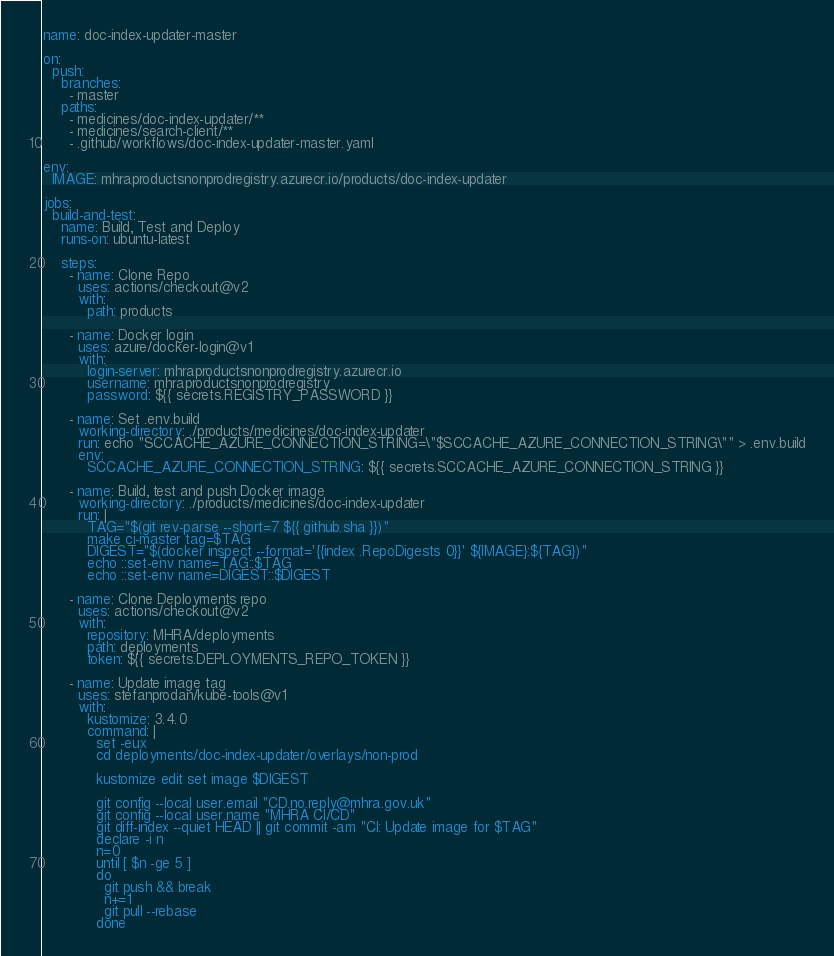<code> <loc_0><loc_0><loc_500><loc_500><_YAML_>name: doc-index-updater-master

on:
  push:
    branches:
      - master
    paths:
      - medicines/doc-index-updater/**
      - medicines/search-client/**
      - .github/workflows/doc-index-updater-master.yaml

env:
  IMAGE: mhraproductsnonprodregistry.azurecr.io/products/doc-index-updater

jobs:
  build-and-test:
    name: Build, Test and Deploy
    runs-on: ubuntu-latest

    steps:
      - name: Clone Repo
        uses: actions/checkout@v2
        with:
          path: products

      - name: Docker login
        uses: azure/docker-login@v1
        with:
          login-server: mhraproductsnonprodregistry.azurecr.io
          username: mhraproductsnonprodregistry
          password: ${{ secrets.REGISTRY_PASSWORD }}

      - name: Set .env.build
        working-directory: ./products/medicines/doc-index-updater
        run: echo "SCCACHE_AZURE_CONNECTION_STRING=\"$SCCACHE_AZURE_CONNECTION_STRING\"" > .env.build
        env:
          SCCACHE_AZURE_CONNECTION_STRING: ${{ secrets.SCCACHE_AZURE_CONNECTION_STRING }}

      - name: Build, test and push Docker image
        working-directory: ./products/medicines/doc-index-updater
        run: |
          TAG="$(git rev-parse --short=7 ${{ github.sha }})"
          make ci-master tag=$TAG
          DIGEST="$(docker inspect --format='{{index .RepoDigests 0}}' ${IMAGE}:${TAG})"
          echo ::set-env name=TAG::$TAG
          echo ::set-env name=DIGEST::$DIGEST

      - name: Clone Deployments repo
        uses: actions/checkout@v2
        with:
          repository: MHRA/deployments
          path: deployments
          token: ${{ secrets.DEPLOYMENTS_REPO_TOKEN }}

      - name: Update image tag
        uses: stefanprodan/kube-tools@v1
        with:
          kustomize: 3.4.0
          command: |
            set -eux
            cd deployments/doc-index-updater/overlays/non-prod

            kustomize edit set image $DIGEST

            git config --local user.email "CD.no.reply@mhra.gov.uk"
            git config --local user.name "MHRA CI/CD"
            git diff-index --quiet HEAD || git commit -am "CI: Update image for $TAG"
            declare -i n
            n=0
            until [ $n -ge 5 ]
            do
              git push && break
              n+=1
              git pull --rebase
            done
</code> 